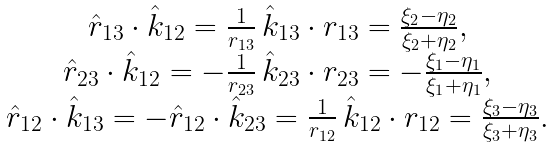Convert formula to latex. <formula><loc_0><loc_0><loc_500><loc_500>\begin{array} { c } \hat { r } _ { 1 3 } \cdot \hat { k } _ { 1 2 } = \frac { 1 } { r _ { 1 3 } } \, \hat { k } _ { 1 3 } \cdot { r } _ { 1 3 } = \frac { \xi _ { 2 } - \eta _ { 2 } } { \xi _ { 2 } + \eta _ { 2 } } , \\ \hat { r } _ { 2 3 } \cdot \hat { k } _ { 1 2 } = - \frac { 1 } { r _ { 2 3 } } \, \hat { k } _ { 2 3 } \cdot { r } _ { 2 3 } = - \frac { \xi _ { 1 } - \eta _ { 1 } } { \xi _ { 1 } + \eta _ { 1 } } , \\ \hat { r } _ { 1 2 } \cdot \hat { k } _ { 1 3 } = - \hat { r } _ { 1 2 } \cdot \hat { k } _ { 2 3 } = \frac { 1 } { r _ { 1 2 } } \, \hat { k } _ { 1 2 } \cdot { r } _ { 1 2 } = \frac { \xi _ { 3 } - \eta _ { 3 } } { \xi _ { 3 } + \eta _ { 3 } } . \\ \end{array}</formula> 